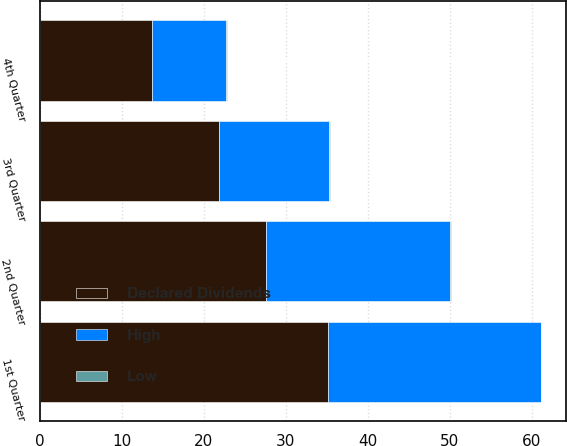Convert chart to OTSL. <chart><loc_0><loc_0><loc_500><loc_500><stacked_bar_chart><ecel><fcel>1st Quarter<fcel>2nd Quarter<fcel>3rd Quarter<fcel>4th Quarter<nl><fcel>Declared Dividends<fcel>35.1<fcel>27.61<fcel>21.85<fcel>13.68<nl><fcel>High<fcel>25.99<fcel>22.45<fcel>13.47<fcel>9.08<nl><fcel>Low<fcel>0.04<fcel>0.04<fcel>0.04<fcel>0.04<nl></chart> 